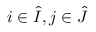Convert formula to latex. <formula><loc_0><loc_0><loc_500><loc_500>i \in \hat { I } , j \in \hat { J }</formula> 